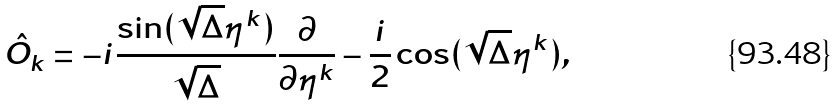<formula> <loc_0><loc_0><loc_500><loc_500>\hat { O } _ { k } = - i \frac { \sin ( \sqrt { \Delta } \eta ^ { k } ) } { \sqrt { \Delta } } \frac { \partial } { \partial \eta ^ { k } } - \frac { i } { 2 } \cos ( \sqrt { \Delta } \eta ^ { k } ) ,</formula> 